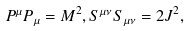Convert formula to latex. <formula><loc_0><loc_0><loc_500><loc_500>P ^ { \mu } P _ { \mu } = M ^ { 2 } , S ^ { \mu \nu } S _ { \mu \nu } = 2 J ^ { 2 } ,</formula> 